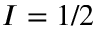<formula> <loc_0><loc_0><loc_500><loc_500>I = 1 / 2</formula> 